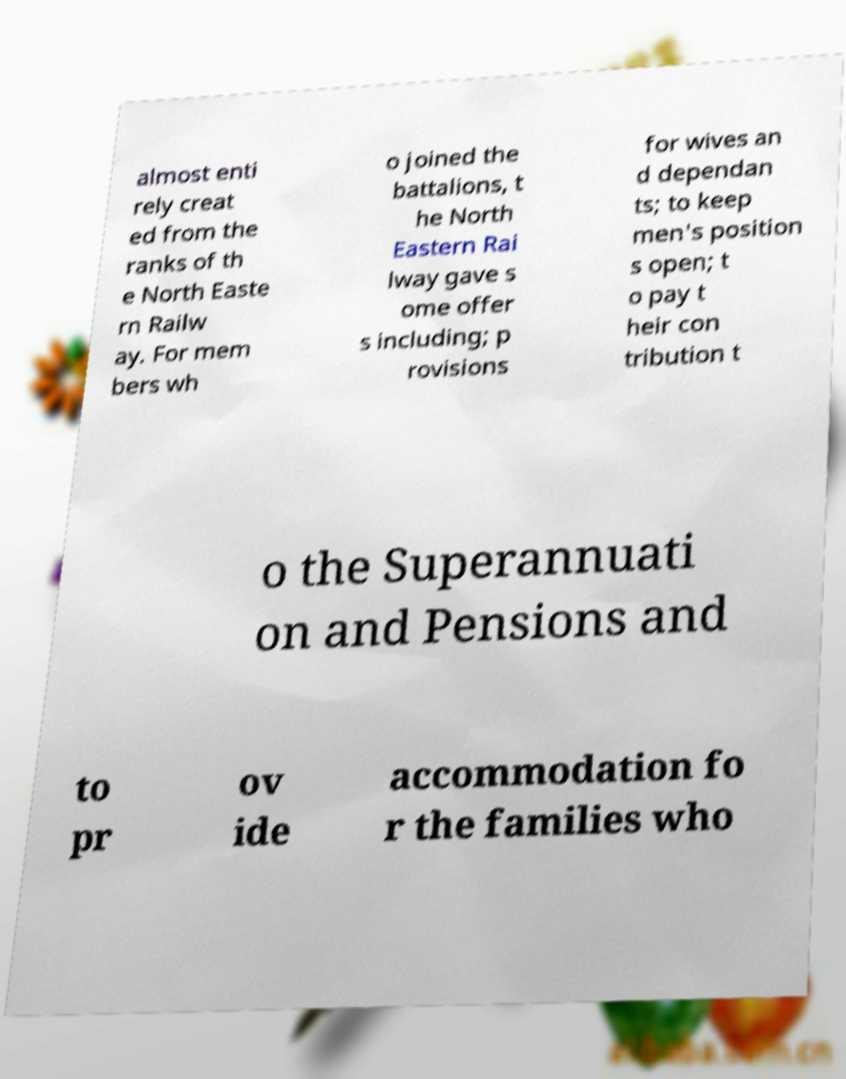Can you accurately transcribe the text from the provided image for me? almost enti rely creat ed from the ranks of th e North Easte rn Railw ay. For mem bers wh o joined the battalions, t he North Eastern Rai lway gave s ome offer s including; p rovisions for wives an d dependan ts; to keep men's position s open; t o pay t heir con tribution t o the Superannuati on and Pensions and to pr ov ide accommodation fo r the families who 